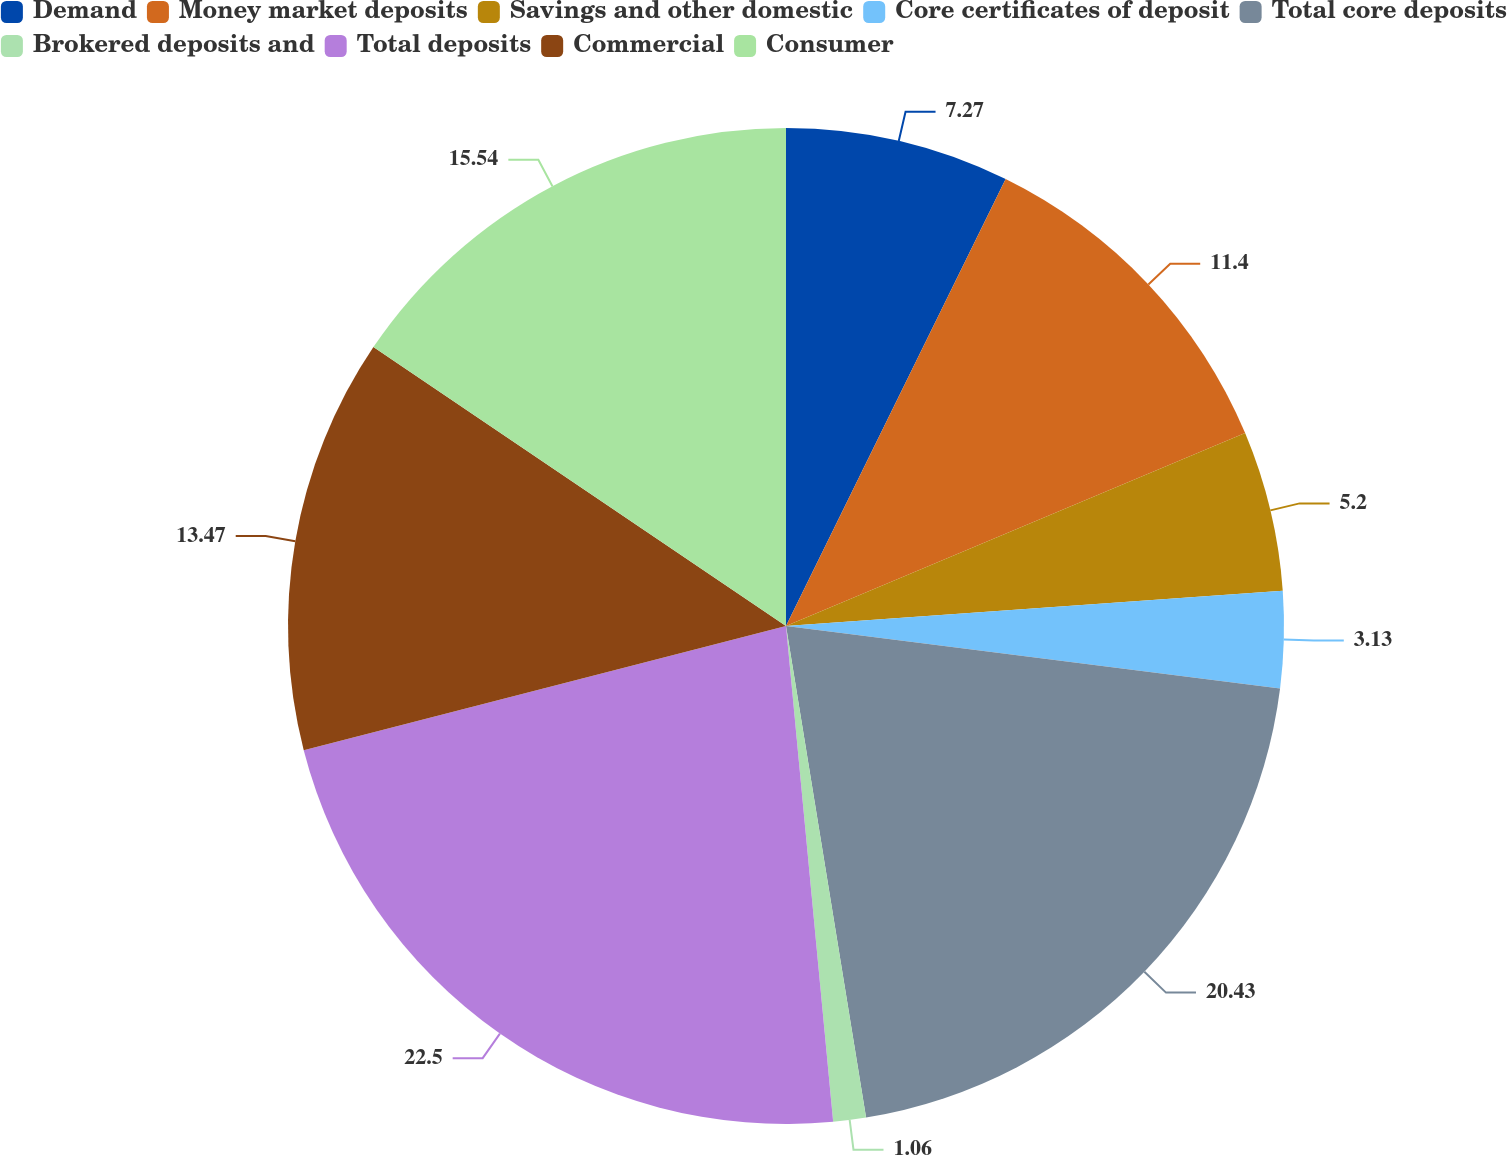Convert chart to OTSL. <chart><loc_0><loc_0><loc_500><loc_500><pie_chart><fcel>Demand<fcel>Money market deposits<fcel>Savings and other domestic<fcel>Core certificates of deposit<fcel>Total core deposits<fcel>Brokered deposits and<fcel>Total deposits<fcel>Commercial<fcel>Consumer<nl><fcel>7.27%<fcel>11.4%<fcel>5.2%<fcel>3.13%<fcel>20.43%<fcel>1.06%<fcel>22.5%<fcel>13.47%<fcel>15.54%<nl></chart> 